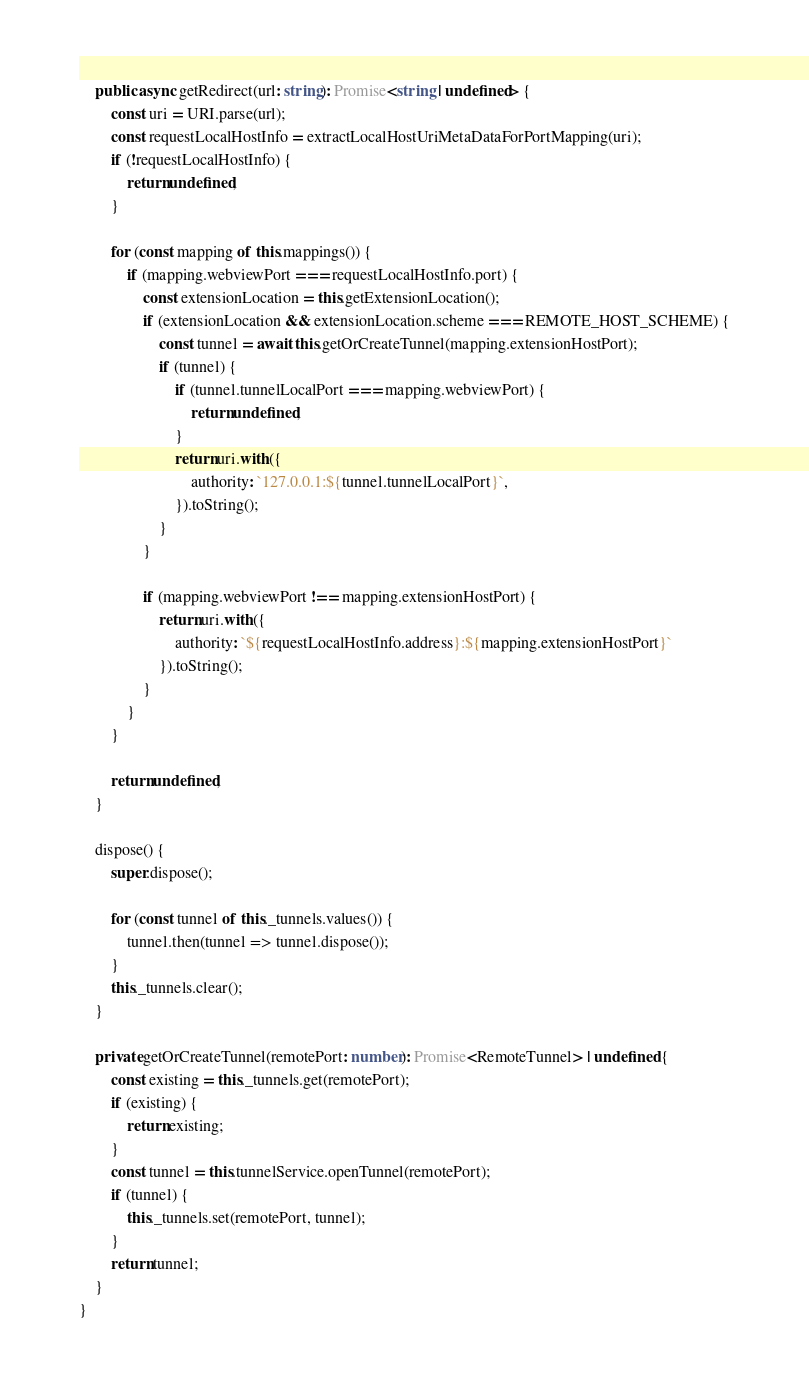Convert code to text. <code><loc_0><loc_0><loc_500><loc_500><_TypeScript_>
	public async getRedirect(url: string): Promise<string | undefined> {
		const uri = URI.parse(url);
		const requestLocalHostInfo = extractLocalHostUriMetaDataForPortMapping(uri);
		if (!requestLocalHostInfo) {
			return undefined;
		}

		for (const mapping of this.mappings()) {
			if (mapping.webviewPort === requestLocalHostInfo.port) {
				const extensionLocation = this.getExtensionLocation();
				if (extensionLocation && extensionLocation.scheme === REMOTE_HOST_SCHEME) {
					const tunnel = await this.getOrCreateTunnel(mapping.extensionHostPort);
					if (tunnel) {
						if (tunnel.tunnelLocalPort === mapping.webviewPort) {
							return undefined;
						}
						return uri.with({
							authority: `127.0.0.1:${tunnel.tunnelLocalPort}`,
						}).toString();
					}
				}

				if (mapping.webviewPort !== mapping.extensionHostPort) {
					return uri.with({
						authority: `${requestLocalHostInfo.address}:${mapping.extensionHostPort}`
					}).toString();
				}
			}
		}

		return undefined;
	}

	dispose() {
		super.dispose();

		for (const tunnel of this._tunnels.values()) {
			tunnel.then(tunnel => tunnel.dispose());
		}
		this._tunnels.clear();
	}

	private getOrCreateTunnel(remotePort: number): Promise<RemoteTunnel> | undefined {
		const existing = this._tunnels.get(remotePort);
		if (existing) {
			return existing;
		}
		const tunnel = this.tunnelService.openTunnel(remotePort);
		if (tunnel) {
			this._tunnels.set(remotePort, tunnel);
		}
		return tunnel;
	}
}
</code> 